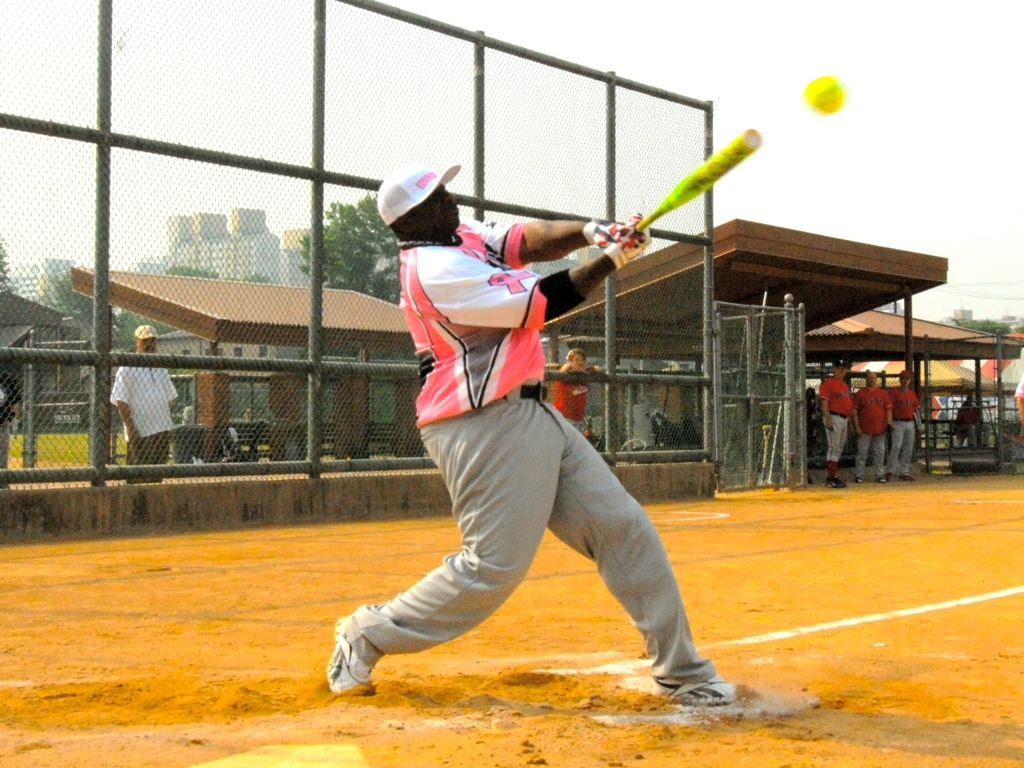Can you describe the action taking place in the image? Certainly! The image captures a moment during a softball game. We see a player in mid-swing after hitting the ball, which can be seen in motion just in front of the bat. The player's posture and facial expression indicate a powerful swing, and the focus on the player highlights the intensity of the action. 